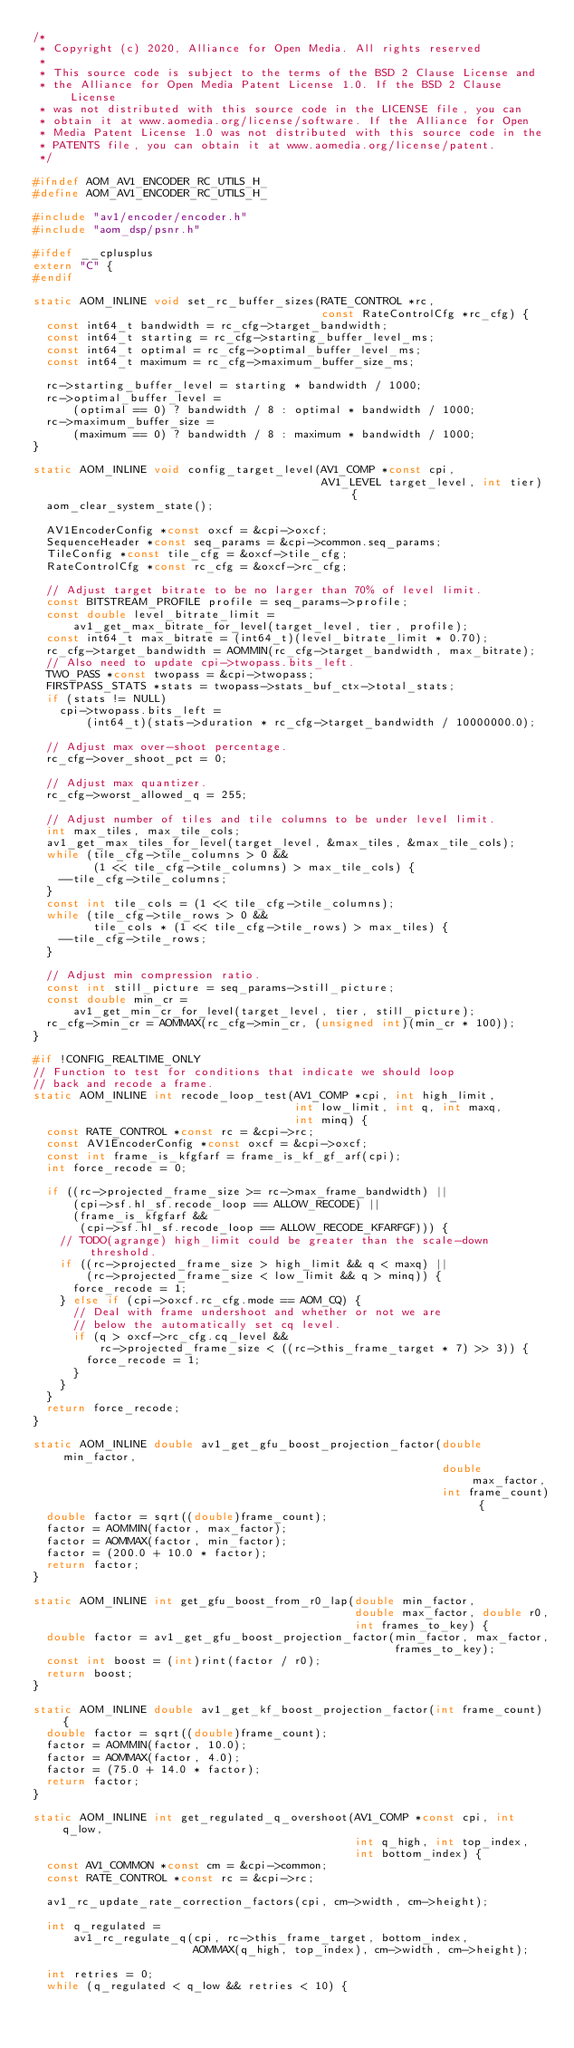<code> <loc_0><loc_0><loc_500><loc_500><_C_>/*
 * Copyright (c) 2020, Alliance for Open Media. All rights reserved
 *
 * This source code is subject to the terms of the BSD 2 Clause License and
 * the Alliance for Open Media Patent License 1.0. If the BSD 2 Clause License
 * was not distributed with this source code in the LICENSE file, you can
 * obtain it at www.aomedia.org/license/software. If the Alliance for Open
 * Media Patent License 1.0 was not distributed with this source code in the
 * PATENTS file, you can obtain it at www.aomedia.org/license/patent.
 */

#ifndef AOM_AV1_ENCODER_RC_UTILS_H_
#define AOM_AV1_ENCODER_RC_UTILS_H_

#include "av1/encoder/encoder.h"
#include "aom_dsp/psnr.h"

#ifdef __cplusplus
extern "C" {
#endif

static AOM_INLINE void set_rc_buffer_sizes(RATE_CONTROL *rc,
                                           const RateControlCfg *rc_cfg) {
  const int64_t bandwidth = rc_cfg->target_bandwidth;
  const int64_t starting = rc_cfg->starting_buffer_level_ms;
  const int64_t optimal = rc_cfg->optimal_buffer_level_ms;
  const int64_t maximum = rc_cfg->maximum_buffer_size_ms;

  rc->starting_buffer_level = starting * bandwidth / 1000;
  rc->optimal_buffer_level =
      (optimal == 0) ? bandwidth / 8 : optimal * bandwidth / 1000;
  rc->maximum_buffer_size =
      (maximum == 0) ? bandwidth / 8 : maximum * bandwidth / 1000;
}

static AOM_INLINE void config_target_level(AV1_COMP *const cpi,
                                           AV1_LEVEL target_level, int tier) {
  aom_clear_system_state();

  AV1EncoderConfig *const oxcf = &cpi->oxcf;
  SequenceHeader *const seq_params = &cpi->common.seq_params;
  TileConfig *const tile_cfg = &oxcf->tile_cfg;
  RateControlCfg *const rc_cfg = &oxcf->rc_cfg;

  // Adjust target bitrate to be no larger than 70% of level limit.
  const BITSTREAM_PROFILE profile = seq_params->profile;
  const double level_bitrate_limit =
      av1_get_max_bitrate_for_level(target_level, tier, profile);
  const int64_t max_bitrate = (int64_t)(level_bitrate_limit * 0.70);
  rc_cfg->target_bandwidth = AOMMIN(rc_cfg->target_bandwidth, max_bitrate);
  // Also need to update cpi->twopass.bits_left.
  TWO_PASS *const twopass = &cpi->twopass;
  FIRSTPASS_STATS *stats = twopass->stats_buf_ctx->total_stats;
  if (stats != NULL)
    cpi->twopass.bits_left =
        (int64_t)(stats->duration * rc_cfg->target_bandwidth / 10000000.0);

  // Adjust max over-shoot percentage.
  rc_cfg->over_shoot_pct = 0;

  // Adjust max quantizer.
  rc_cfg->worst_allowed_q = 255;

  // Adjust number of tiles and tile columns to be under level limit.
  int max_tiles, max_tile_cols;
  av1_get_max_tiles_for_level(target_level, &max_tiles, &max_tile_cols);
  while (tile_cfg->tile_columns > 0 &&
         (1 << tile_cfg->tile_columns) > max_tile_cols) {
    --tile_cfg->tile_columns;
  }
  const int tile_cols = (1 << tile_cfg->tile_columns);
  while (tile_cfg->tile_rows > 0 &&
         tile_cols * (1 << tile_cfg->tile_rows) > max_tiles) {
    --tile_cfg->tile_rows;
  }

  // Adjust min compression ratio.
  const int still_picture = seq_params->still_picture;
  const double min_cr =
      av1_get_min_cr_for_level(target_level, tier, still_picture);
  rc_cfg->min_cr = AOMMAX(rc_cfg->min_cr, (unsigned int)(min_cr * 100));
}

#if !CONFIG_REALTIME_ONLY
// Function to test for conditions that indicate we should loop
// back and recode a frame.
static AOM_INLINE int recode_loop_test(AV1_COMP *cpi, int high_limit,
                                       int low_limit, int q, int maxq,
                                       int minq) {
  const RATE_CONTROL *const rc = &cpi->rc;
  const AV1EncoderConfig *const oxcf = &cpi->oxcf;
  const int frame_is_kfgfarf = frame_is_kf_gf_arf(cpi);
  int force_recode = 0;

  if ((rc->projected_frame_size >= rc->max_frame_bandwidth) ||
      (cpi->sf.hl_sf.recode_loop == ALLOW_RECODE) ||
      (frame_is_kfgfarf &&
       (cpi->sf.hl_sf.recode_loop == ALLOW_RECODE_KFARFGF))) {
    // TODO(agrange) high_limit could be greater than the scale-down threshold.
    if ((rc->projected_frame_size > high_limit && q < maxq) ||
        (rc->projected_frame_size < low_limit && q > minq)) {
      force_recode = 1;
    } else if (cpi->oxcf.rc_cfg.mode == AOM_CQ) {
      // Deal with frame undershoot and whether or not we are
      // below the automatically set cq level.
      if (q > oxcf->rc_cfg.cq_level &&
          rc->projected_frame_size < ((rc->this_frame_target * 7) >> 3)) {
        force_recode = 1;
      }
    }
  }
  return force_recode;
}

static AOM_INLINE double av1_get_gfu_boost_projection_factor(double min_factor,
                                                             double max_factor,
                                                             int frame_count) {
  double factor = sqrt((double)frame_count);
  factor = AOMMIN(factor, max_factor);
  factor = AOMMAX(factor, min_factor);
  factor = (200.0 + 10.0 * factor);
  return factor;
}

static AOM_INLINE int get_gfu_boost_from_r0_lap(double min_factor,
                                                double max_factor, double r0,
                                                int frames_to_key) {
  double factor = av1_get_gfu_boost_projection_factor(min_factor, max_factor,
                                                      frames_to_key);
  const int boost = (int)rint(factor / r0);
  return boost;
}

static AOM_INLINE double av1_get_kf_boost_projection_factor(int frame_count) {
  double factor = sqrt((double)frame_count);
  factor = AOMMIN(factor, 10.0);
  factor = AOMMAX(factor, 4.0);
  factor = (75.0 + 14.0 * factor);
  return factor;
}

static AOM_INLINE int get_regulated_q_overshoot(AV1_COMP *const cpi, int q_low,
                                                int q_high, int top_index,
                                                int bottom_index) {
  const AV1_COMMON *const cm = &cpi->common;
  const RATE_CONTROL *const rc = &cpi->rc;

  av1_rc_update_rate_correction_factors(cpi, cm->width, cm->height);

  int q_regulated =
      av1_rc_regulate_q(cpi, rc->this_frame_target, bottom_index,
                        AOMMAX(q_high, top_index), cm->width, cm->height);

  int retries = 0;
  while (q_regulated < q_low && retries < 10) {</code> 